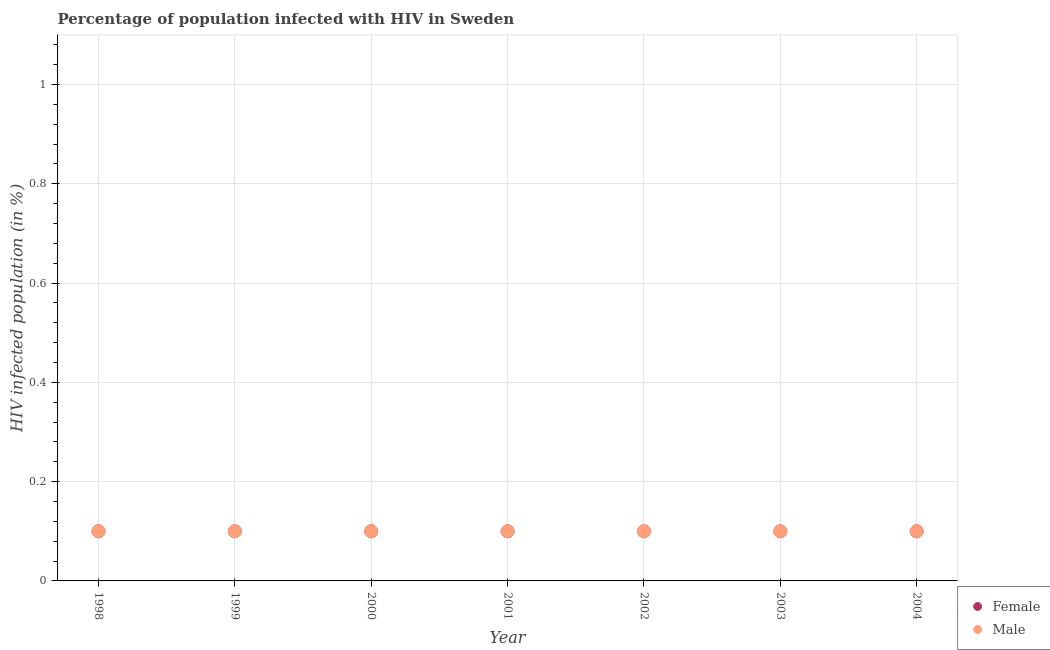Across all years, what is the maximum percentage of females who are infected with hiv?
Offer a terse response. 0.1. In which year was the percentage of females who are infected with hiv minimum?
Your answer should be very brief. 1998. What is the average percentage of females who are infected with hiv per year?
Offer a very short reply. 0.1. In the year 2000, what is the difference between the percentage of males who are infected with hiv and percentage of females who are infected with hiv?
Offer a very short reply. 0. In how many years, is the percentage of males who are infected with hiv greater than 0.8400000000000001 %?
Offer a very short reply. 0. Is the difference between the percentage of males who are infected with hiv in 2000 and 2003 greater than the difference between the percentage of females who are infected with hiv in 2000 and 2003?
Make the answer very short. No. What is the difference between the highest and the second highest percentage of females who are infected with hiv?
Ensure brevity in your answer.  0. Is the percentage of males who are infected with hiv strictly greater than the percentage of females who are infected with hiv over the years?
Your response must be concise. No. Is the percentage of females who are infected with hiv strictly less than the percentage of males who are infected with hiv over the years?
Your answer should be compact. No. How many years are there in the graph?
Give a very brief answer. 7. What is the difference between two consecutive major ticks on the Y-axis?
Ensure brevity in your answer.  0.2. Does the graph contain any zero values?
Give a very brief answer. No. Does the graph contain grids?
Offer a very short reply. Yes. What is the title of the graph?
Provide a short and direct response. Percentage of population infected with HIV in Sweden. Does "State government" appear as one of the legend labels in the graph?
Give a very brief answer. No. What is the label or title of the X-axis?
Keep it short and to the point. Year. What is the label or title of the Y-axis?
Keep it short and to the point. HIV infected population (in %). What is the HIV infected population (in %) in Female in 2000?
Give a very brief answer. 0.1. What is the HIV infected population (in %) in Male in 2000?
Provide a short and direct response. 0.1. What is the HIV infected population (in %) of Male in 2002?
Your answer should be compact. 0.1. What is the HIV infected population (in %) of Female in 2003?
Your answer should be very brief. 0.1. What is the HIV infected population (in %) in Male in 2003?
Provide a succinct answer. 0.1. What is the HIV infected population (in %) of Male in 2004?
Offer a very short reply. 0.1. Across all years, what is the maximum HIV infected population (in %) of Female?
Make the answer very short. 0.1. Across all years, what is the minimum HIV infected population (in %) of Female?
Give a very brief answer. 0.1. Across all years, what is the minimum HIV infected population (in %) in Male?
Provide a short and direct response. 0.1. What is the total HIV infected population (in %) in Female in the graph?
Offer a terse response. 0.7. What is the total HIV infected population (in %) of Male in the graph?
Offer a terse response. 0.7. What is the difference between the HIV infected population (in %) of Female in 1998 and that in 1999?
Give a very brief answer. 0. What is the difference between the HIV infected population (in %) in Female in 1998 and that in 2000?
Offer a very short reply. 0. What is the difference between the HIV infected population (in %) in Female in 1998 and that in 2002?
Your answer should be very brief. 0. What is the difference between the HIV infected population (in %) of Male in 1998 and that in 2002?
Give a very brief answer. 0. What is the difference between the HIV infected population (in %) of Female in 1998 and that in 2003?
Your answer should be compact. 0. What is the difference between the HIV infected population (in %) in Female in 1998 and that in 2004?
Make the answer very short. 0. What is the difference between the HIV infected population (in %) of Female in 1999 and that in 2000?
Provide a succinct answer. 0. What is the difference between the HIV infected population (in %) of Male in 1999 and that in 2000?
Provide a succinct answer. 0. What is the difference between the HIV infected population (in %) of Male in 1999 and that in 2001?
Your answer should be compact. 0. What is the difference between the HIV infected population (in %) in Male in 1999 and that in 2002?
Offer a very short reply. 0. What is the difference between the HIV infected population (in %) of Female in 1999 and that in 2003?
Keep it short and to the point. 0. What is the difference between the HIV infected population (in %) of Female in 1999 and that in 2004?
Provide a short and direct response. 0. What is the difference between the HIV infected population (in %) of Male in 2000 and that in 2001?
Make the answer very short. 0. What is the difference between the HIV infected population (in %) of Female in 2000 and that in 2002?
Your answer should be very brief. 0. What is the difference between the HIV infected population (in %) in Female in 2000 and that in 2003?
Your answer should be compact. 0. What is the difference between the HIV infected population (in %) of Male in 2000 and that in 2003?
Ensure brevity in your answer.  0. What is the difference between the HIV infected population (in %) of Female in 2000 and that in 2004?
Make the answer very short. 0. What is the difference between the HIV infected population (in %) in Male in 2000 and that in 2004?
Provide a succinct answer. 0. What is the difference between the HIV infected population (in %) in Female in 2001 and that in 2002?
Provide a short and direct response. 0. What is the difference between the HIV infected population (in %) in Female in 2001 and that in 2004?
Ensure brevity in your answer.  0. What is the difference between the HIV infected population (in %) of Female in 2002 and that in 2003?
Your response must be concise. 0. What is the difference between the HIV infected population (in %) of Male in 2002 and that in 2003?
Make the answer very short. 0. What is the difference between the HIV infected population (in %) in Female in 2002 and that in 2004?
Offer a terse response. 0. What is the difference between the HIV infected population (in %) in Male in 2002 and that in 2004?
Make the answer very short. 0. What is the difference between the HIV infected population (in %) of Female in 1998 and the HIV infected population (in %) of Male in 2000?
Your answer should be very brief. 0. What is the difference between the HIV infected population (in %) of Female in 1998 and the HIV infected population (in %) of Male in 2001?
Provide a succinct answer. 0. What is the difference between the HIV infected population (in %) in Female in 1998 and the HIV infected population (in %) in Male in 2002?
Your answer should be very brief. 0. What is the difference between the HIV infected population (in %) of Female in 1998 and the HIV infected population (in %) of Male in 2003?
Give a very brief answer. 0. What is the difference between the HIV infected population (in %) in Female in 1999 and the HIV infected population (in %) in Male in 2001?
Keep it short and to the point. 0. What is the difference between the HIV infected population (in %) of Female in 1999 and the HIV infected population (in %) of Male in 2003?
Offer a very short reply. 0. What is the difference between the HIV infected population (in %) in Female in 1999 and the HIV infected population (in %) in Male in 2004?
Ensure brevity in your answer.  0. What is the difference between the HIV infected population (in %) of Female in 2000 and the HIV infected population (in %) of Male in 2001?
Your response must be concise. 0. What is the difference between the HIV infected population (in %) of Female in 2000 and the HIV infected population (in %) of Male in 2004?
Provide a short and direct response. 0. What is the difference between the HIV infected population (in %) of Female in 2001 and the HIV infected population (in %) of Male in 2002?
Your answer should be compact. 0. What is the difference between the HIV infected population (in %) in Female in 2001 and the HIV infected population (in %) in Male in 2003?
Provide a succinct answer. 0. What is the difference between the HIV infected population (in %) in Female in 2002 and the HIV infected population (in %) in Male in 2003?
Provide a succinct answer. 0. What is the difference between the HIV infected population (in %) in Female in 2003 and the HIV infected population (in %) in Male in 2004?
Make the answer very short. 0. What is the average HIV infected population (in %) in Female per year?
Offer a terse response. 0.1. In the year 1998, what is the difference between the HIV infected population (in %) of Female and HIV infected population (in %) of Male?
Your answer should be very brief. 0. In the year 1999, what is the difference between the HIV infected population (in %) of Female and HIV infected population (in %) of Male?
Keep it short and to the point. 0. In the year 2002, what is the difference between the HIV infected population (in %) of Female and HIV infected population (in %) of Male?
Provide a short and direct response. 0. In the year 2003, what is the difference between the HIV infected population (in %) of Female and HIV infected population (in %) of Male?
Your answer should be very brief. 0. What is the ratio of the HIV infected population (in %) of Male in 1998 to that in 1999?
Your answer should be very brief. 1. What is the ratio of the HIV infected population (in %) in Female in 1998 to that in 2000?
Provide a short and direct response. 1. What is the ratio of the HIV infected population (in %) of Female in 1998 to that in 2001?
Your answer should be very brief. 1. What is the ratio of the HIV infected population (in %) in Female in 1998 to that in 2002?
Offer a terse response. 1. What is the ratio of the HIV infected population (in %) in Female in 1998 to that in 2004?
Keep it short and to the point. 1. What is the ratio of the HIV infected population (in %) in Female in 1999 to that in 2000?
Your answer should be very brief. 1. What is the ratio of the HIV infected population (in %) in Female in 1999 to that in 2002?
Your response must be concise. 1. What is the ratio of the HIV infected population (in %) of Female in 1999 to that in 2003?
Your answer should be very brief. 1. What is the ratio of the HIV infected population (in %) in Female in 1999 to that in 2004?
Offer a terse response. 1. What is the ratio of the HIV infected population (in %) of Male in 2000 to that in 2002?
Your answer should be very brief. 1. What is the ratio of the HIV infected population (in %) of Female in 2000 to that in 2004?
Make the answer very short. 1. What is the ratio of the HIV infected population (in %) in Male in 2000 to that in 2004?
Offer a terse response. 1. What is the ratio of the HIV infected population (in %) in Male in 2001 to that in 2002?
Make the answer very short. 1. What is the ratio of the HIV infected population (in %) of Female in 2001 to that in 2003?
Give a very brief answer. 1. What is the ratio of the HIV infected population (in %) in Female in 2002 to that in 2003?
Provide a short and direct response. 1. What is the ratio of the HIV infected population (in %) of Male in 2002 to that in 2003?
Ensure brevity in your answer.  1. What is the ratio of the HIV infected population (in %) of Male in 2003 to that in 2004?
Offer a very short reply. 1. What is the difference between the highest and the second highest HIV infected population (in %) of Female?
Offer a terse response. 0. What is the difference between the highest and the second highest HIV infected population (in %) in Male?
Your answer should be very brief. 0. What is the difference between the highest and the lowest HIV infected population (in %) in Female?
Your answer should be very brief. 0. 